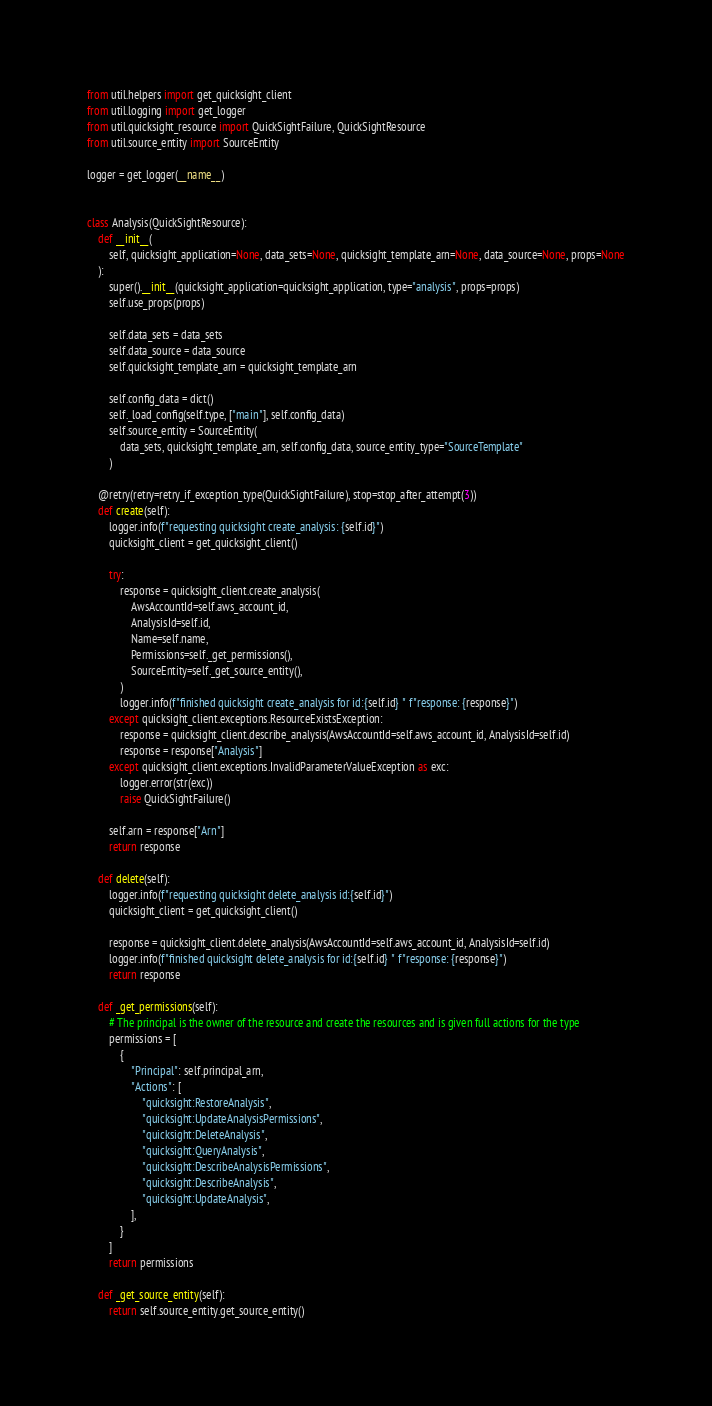Convert code to text. <code><loc_0><loc_0><loc_500><loc_500><_Python_>
from util.helpers import get_quicksight_client
from util.logging import get_logger
from util.quicksight_resource import QuickSightFailure, QuickSightResource
from util.source_entity import SourceEntity

logger = get_logger(__name__)


class Analysis(QuickSightResource):
    def __init__(
        self, quicksight_application=None, data_sets=None, quicksight_template_arn=None, data_source=None, props=None
    ):
        super().__init__(quicksight_application=quicksight_application, type="analysis", props=props)
        self.use_props(props)

        self.data_sets = data_sets
        self.data_source = data_source
        self.quicksight_template_arn = quicksight_template_arn

        self.config_data = dict()
        self._load_config(self.type, ["main"], self.config_data)
        self.source_entity = SourceEntity(
            data_sets, quicksight_template_arn, self.config_data, source_entity_type="SourceTemplate"
        )

    @retry(retry=retry_if_exception_type(QuickSightFailure), stop=stop_after_attempt(3))
    def create(self):
        logger.info(f"requesting quicksight create_analysis: {self.id}")
        quicksight_client = get_quicksight_client()

        try:
            response = quicksight_client.create_analysis(
                AwsAccountId=self.aws_account_id,
                AnalysisId=self.id,
                Name=self.name,
                Permissions=self._get_permissions(),
                SourceEntity=self._get_source_entity(),
            )
            logger.info(f"finished quicksight create_analysis for id:{self.id} " f"response: {response}")
        except quicksight_client.exceptions.ResourceExistsException:
            response = quicksight_client.describe_analysis(AwsAccountId=self.aws_account_id, AnalysisId=self.id)
            response = response["Analysis"]
        except quicksight_client.exceptions.InvalidParameterValueException as exc:
            logger.error(str(exc))
            raise QuickSightFailure()

        self.arn = response["Arn"]
        return response

    def delete(self):
        logger.info(f"requesting quicksight delete_analysis id:{self.id}")
        quicksight_client = get_quicksight_client()

        response = quicksight_client.delete_analysis(AwsAccountId=self.aws_account_id, AnalysisId=self.id)
        logger.info(f"finished quicksight delete_analysis for id:{self.id} " f"response: {response}")
        return response

    def _get_permissions(self):
        # The principal is the owner of the resource and create the resources and is given full actions for the type
        permissions = [
            {
                "Principal": self.principal_arn,
                "Actions": [
                    "quicksight:RestoreAnalysis",
                    "quicksight:UpdateAnalysisPermissions",
                    "quicksight:DeleteAnalysis",
                    "quicksight:QueryAnalysis",
                    "quicksight:DescribeAnalysisPermissions",
                    "quicksight:DescribeAnalysis",
                    "quicksight:UpdateAnalysis",
                ],
            }
        ]
        return permissions

    def _get_source_entity(self):
        return self.source_entity.get_source_entity()
</code> 